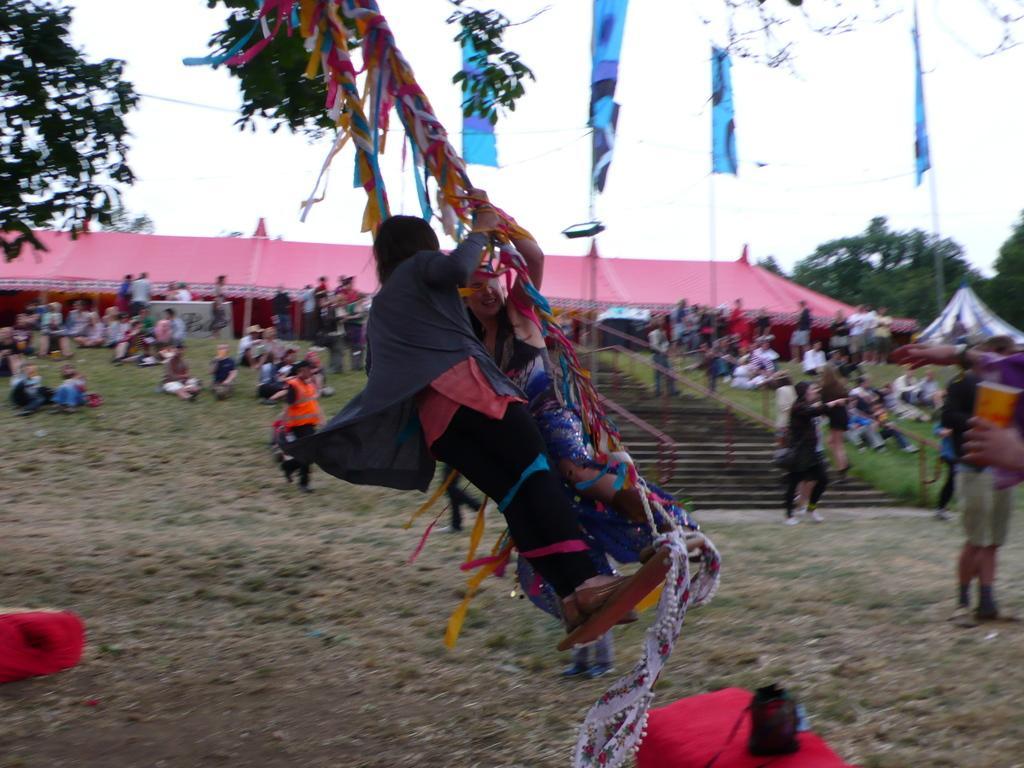Could you give a brief overview of what you see in this image? In the middle of the image two persons are doing swinging. Behind them few people are standing, walking, sitting and we can see some poles, tents, trees and house. At the top of the image we can see the sky. At the bottom of the image we can see the grass. 